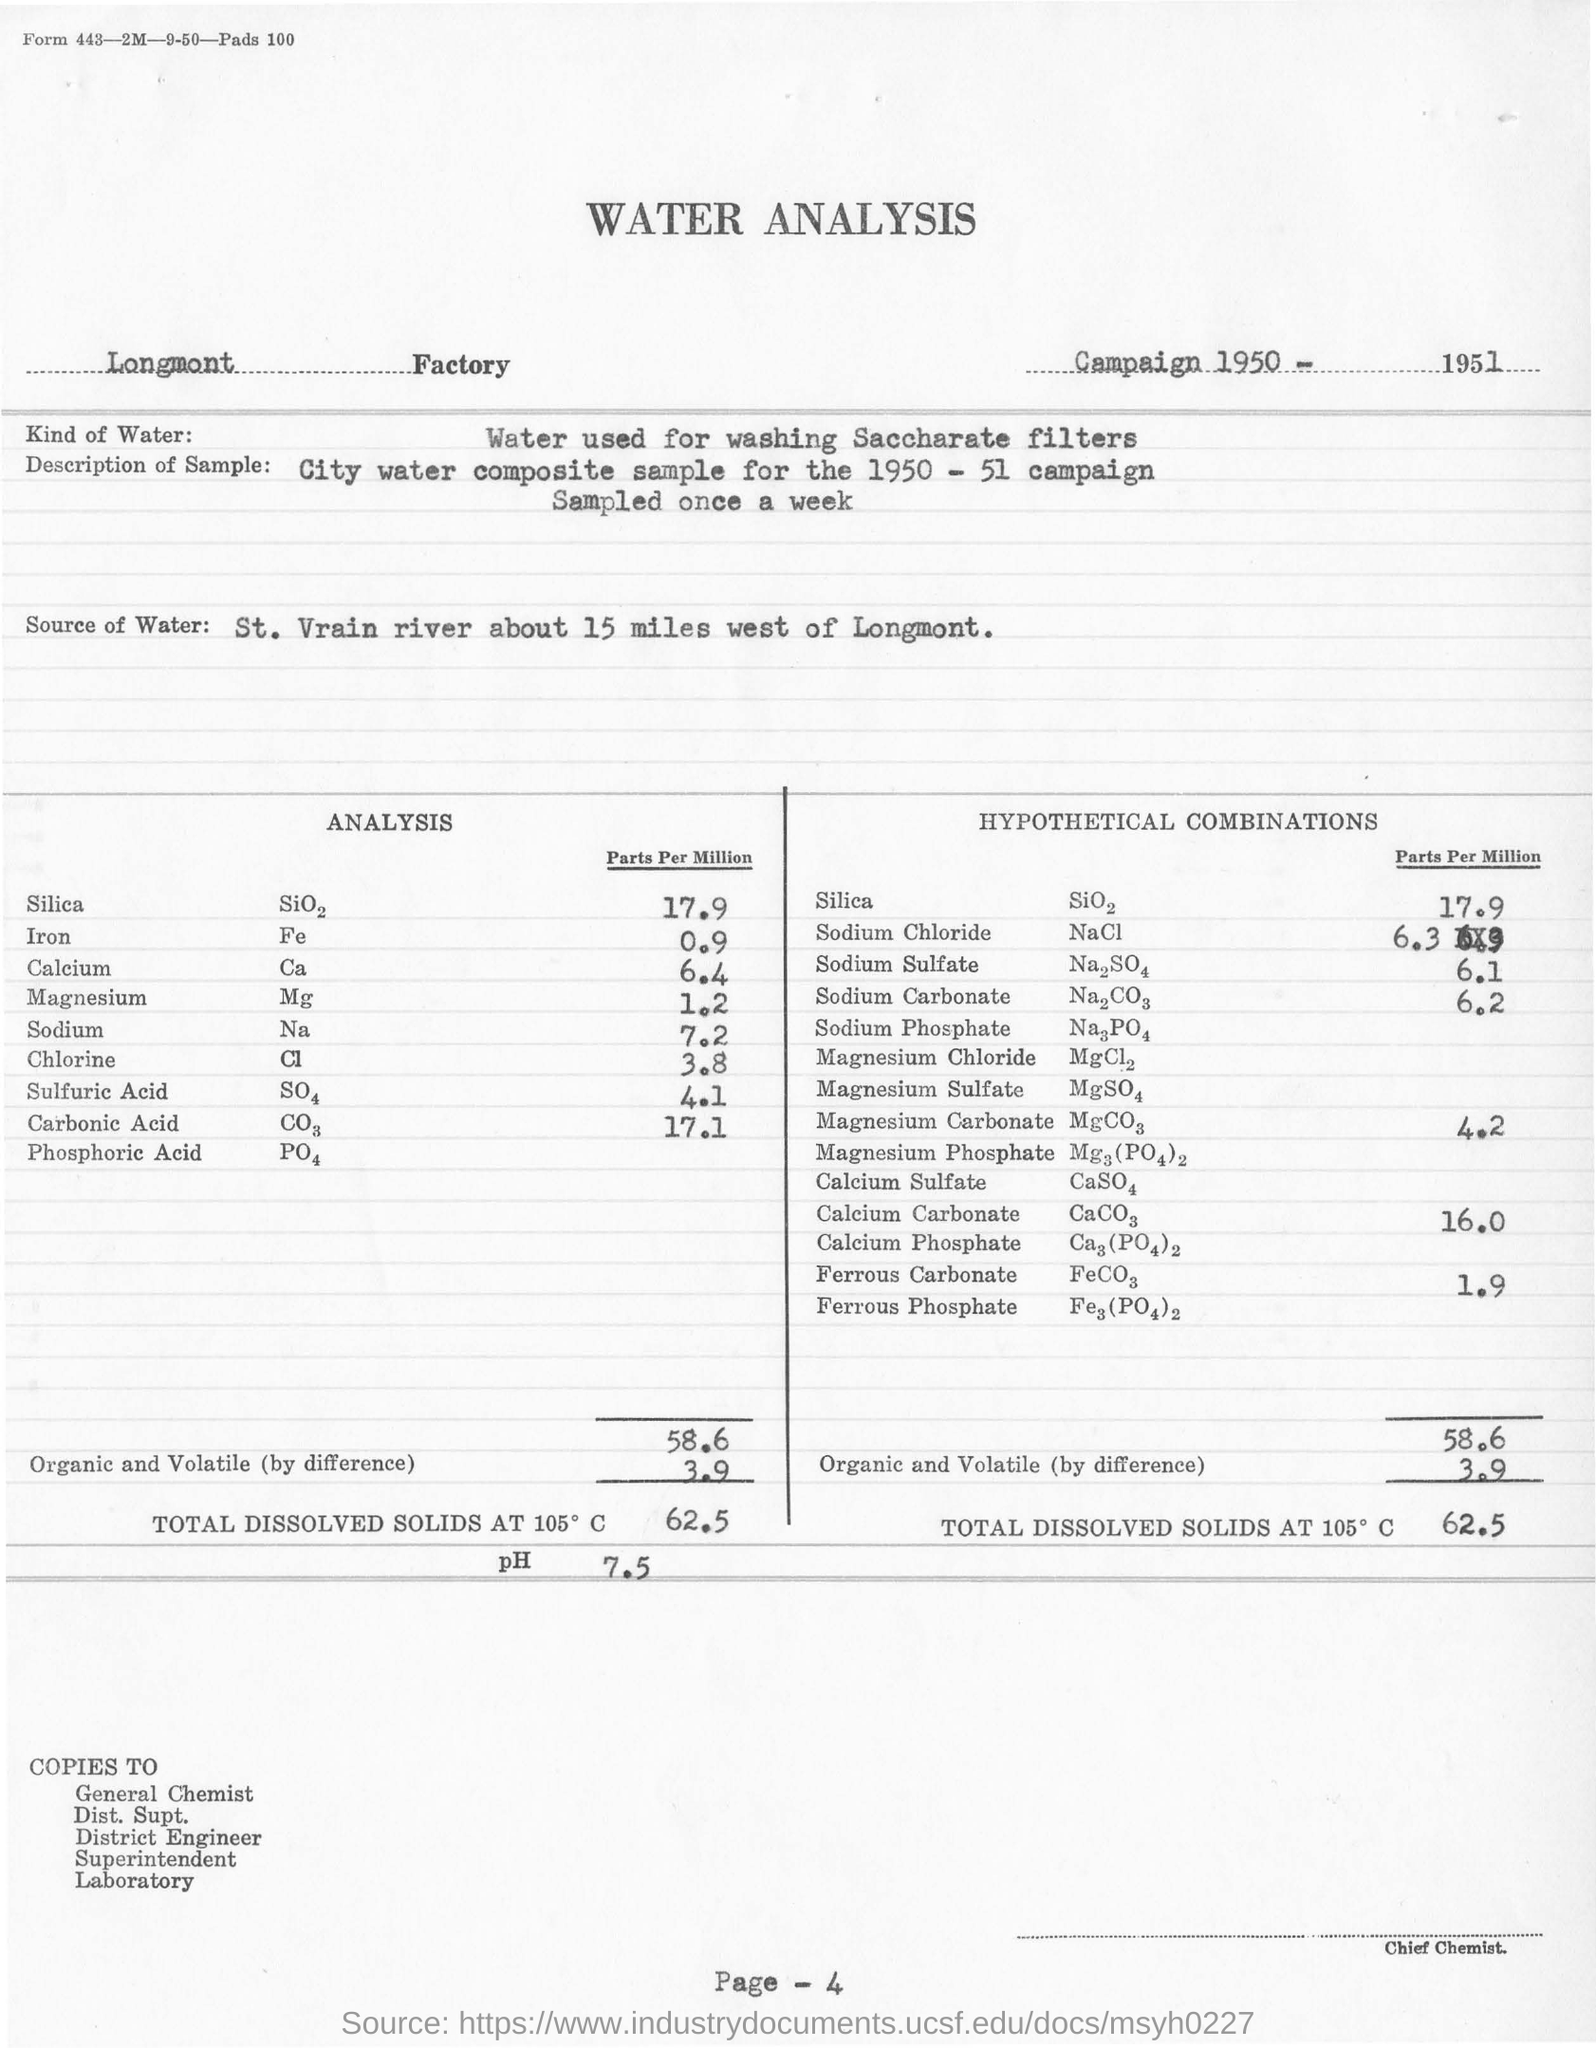List a handful of essential elements in this visual. The analysis revealed that the concentration of sodium in parts per million is 7.2. The analysis revealed a concentration of Silica in parts per million of 17.9. The water used for analysis in this study was sourced from the St. Vrain river, which is located approximately 15 miles west of Longmont, Colorado. The concentration of sodium sulfate in parts per million in the analysis is 6.1. The water analysis is conducted at the Longmont factory. 